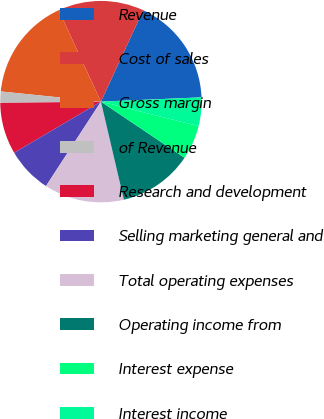Convert chart to OTSL. <chart><loc_0><loc_0><loc_500><loc_500><pie_chart><fcel>Revenue<fcel>Cost of sales<fcel>Gross margin<fcel>of Revenue<fcel>Research and development<fcel>Selling marketing general and<fcel>Total operating expenses<fcel>Operating income from<fcel>Interest expense<fcel>Interest income<nl><fcel>17.43%<fcel>13.76%<fcel>16.51%<fcel>1.83%<fcel>8.26%<fcel>7.34%<fcel>12.84%<fcel>11.93%<fcel>5.5%<fcel>4.59%<nl></chart> 